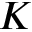Convert formula to latex. <formula><loc_0><loc_0><loc_500><loc_500>K</formula> 